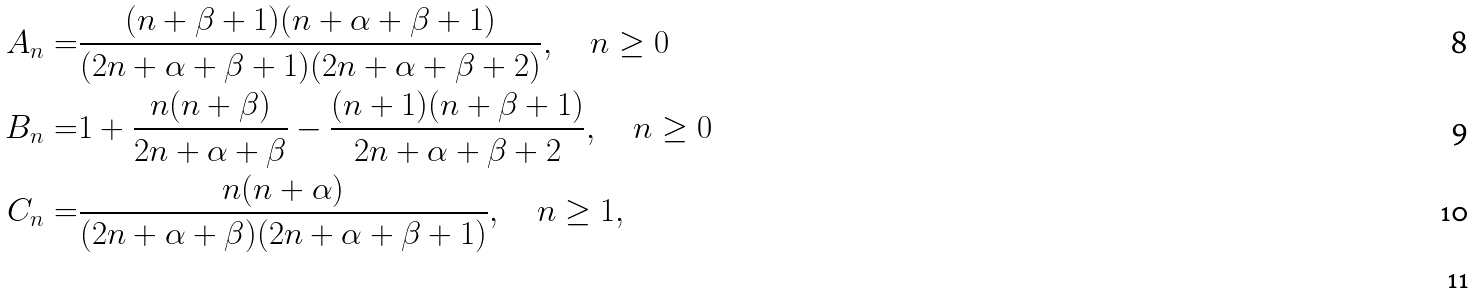Convert formula to latex. <formula><loc_0><loc_0><loc_500><loc_500>A _ { n } = & \frac { ( n + \beta + 1 ) ( n + \alpha + \beta + 1 ) } { ( 2 n + \alpha + \beta + 1 ) ( 2 n + \alpha + \beta + 2 ) } , \quad n \geq 0 \\ B _ { n } = & 1 + \frac { n ( n + \beta ) } { 2 n + \alpha + \beta } - \frac { ( n + 1 ) ( n + \beta + 1 ) } { 2 n + \alpha + \beta + 2 } , \quad n \geq 0 \\ C _ { n } = & \frac { n ( n + \alpha ) } { ( 2 n + \alpha + \beta ) ( 2 n + \alpha + \beta + 1 ) } , \quad n \geq 1 , \\</formula> 